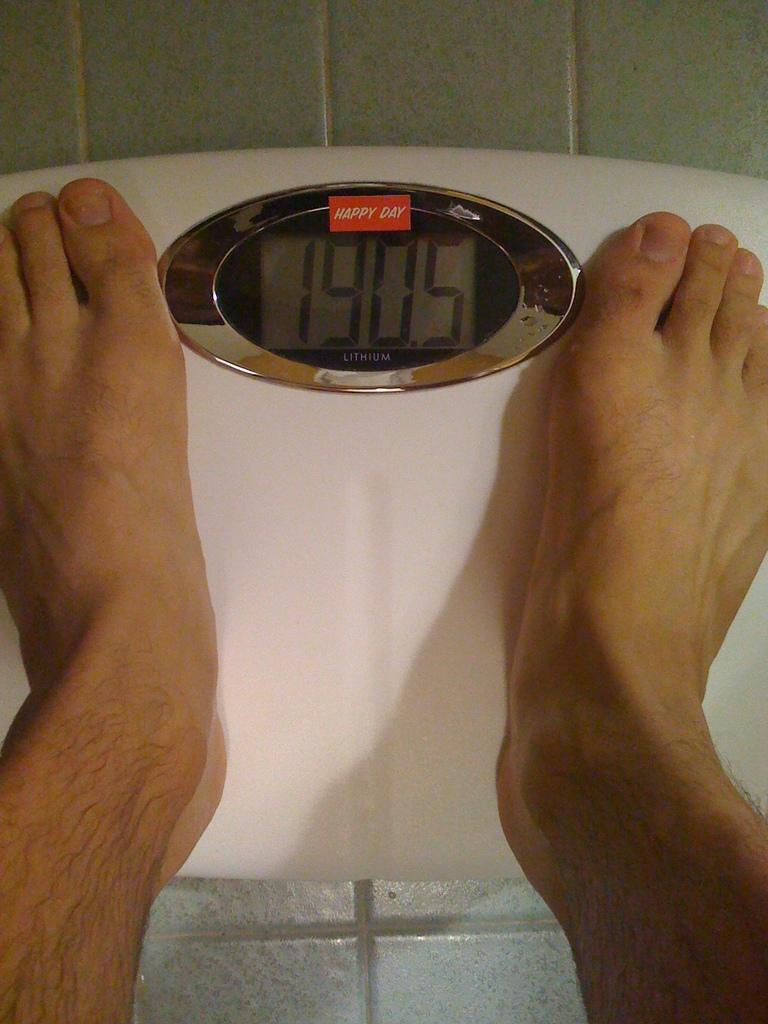<image>
Give a short and clear explanation of the subsequent image. A person standing on a scale that reads 190.5 